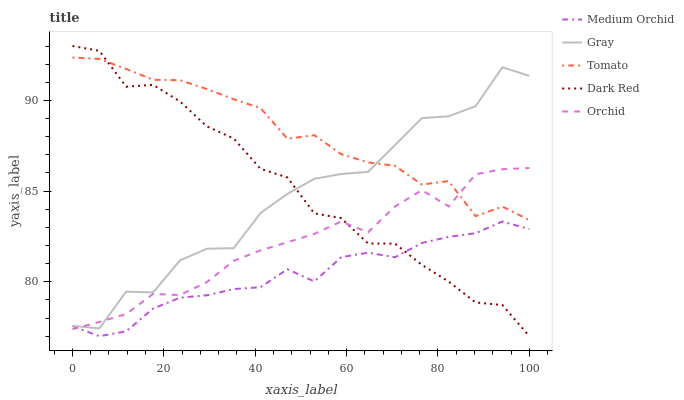Does Medium Orchid have the minimum area under the curve?
Answer yes or no. Yes. Does Tomato have the maximum area under the curve?
Answer yes or no. Yes. Does Gray have the minimum area under the curve?
Answer yes or no. No. Does Gray have the maximum area under the curve?
Answer yes or no. No. Is Medium Orchid the smoothest?
Answer yes or no. Yes. Is Gray the roughest?
Answer yes or no. Yes. Is Gray the smoothest?
Answer yes or no. No. Is Medium Orchid the roughest?
Answer yes or no. No. Does Medium Orchid have the lowest value?
Answer yes or no. Yes. Does Gray have the lowest value?
Answer yes or no. No. Does Dark Red have the highest value?
Answer yes or no. Yes. Does Gray have the highest value?
Answer yes or no. No. Is Medium Orchid less than Gray?
Answer yes or no. Yes. Is Tomato greater than Medium Orchid?
Answer yes or no. Yes. Does Dark Red intersect Orchid?
Answer yes or no. Yes. Is Dark Red less than Orchid?
Answer yes or no. No. Is Dark Red greater than Orchid?
Answer yes or no. No. Does Medium Orchid intersect Gray?
Answer yes or no. No. 